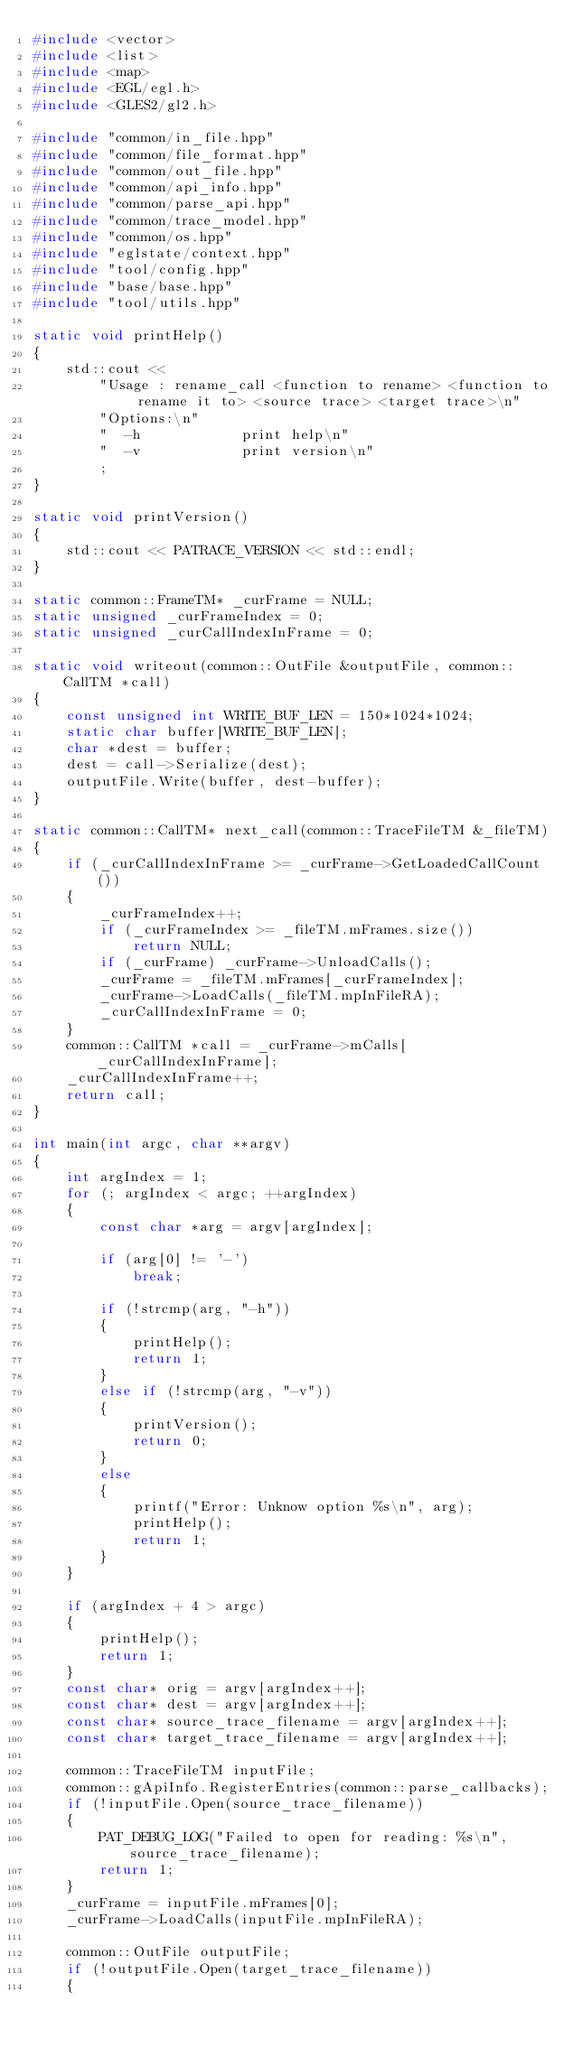<code> <loc_0><loc_0><loc_500><loc_500><_C++_>#include <vector>
#include <list>
#include <map>
#include <EGL/egl.h>
#include <GLES2/gl2.h>

#include "common/in_file.hpp"
#include "common/file_format.hpp"
#include "common/out_file.hpp"
#include "common/api_info.hpp"
#include "common/parse_api.hpp"
#include "common/trace_model.hpp"
#include "common/os.hpp"
#include "eglstate/context.hpp"
#include "tool/config.hpp"
#include "base/base.hpp"
#include "tool/utils.hpp"

static void printHelp()
{
    std::cout <<
        "Usage : rename_call <function to rename> <function to rename it to> <source trace> <target trace>\n"
        "Options:\n"
        "  -h            print help\n"
        "  -v            print version\n"
        ;
}

static void printVersion()
{
    std::cout << PATRACE_VERSION << std::endl;
}

static common::FrameTM* _curFrame = NULL;
static unsigned _curFrameIndex = 0;
static unsigned _curCallIndexInFrame = 0;

static void writeout(common::OutFile &outputFile, common::CallTM *call)
{
    const unsigned int WRITE_BUF_LEN = 150*1024*1024;
    static char buffer[WRITE_BUF_LEN];
    char *dest = buffer;
    dest = call->Serialize(dest);
    outputFile.Write(buffer, dest-buffer);
}

static common::CallTM* next_call(common::TraceFileTM &_fileTM)
{
    if (_curCallIndexInFrame >= _curFrame->GetLoadedCallCount())
    {
        _curFrameIndex++;
        if (_curFrameIndex >= _fileTM.mFrames.size())
            return NULL;
        if (_curFrame) _curFrame->UnloadCalls();
        _curFrame = _fileTM.mFrames[_curFrameIndex];
        _curFrame->LoadCalls(_fileTM.mpInFileRA);
        _curCallIndexInFrame = 0;
    }
    common::CallTM *call = _curFrame->mCalls[_curCallIndexInFrame];
    _curCallIndexInFrame++;
    return call;
}

int main(int argc, char **argv)
{
    int argIndex = 1;
    for (; argIndex < argc; ++argIndex)
    {
        const char *arg = argv[argIndex];

        if (arg[0] != '-')
            break;

        if (!strcmp(arg, "-h"))
        {
            printHelp();
            return 1;
        }
        else if (!strcmp(arg, "-v"))
        {
            printVersion();
            return 0;
        }
        else
        {
            printf("Error: Unknow option %s\n", arg);
            printHelp();
            return 1;
        }
    }

    if (argIndex + 4 > argc)
    {
        printHelp();
        return 1;
    }
    const char* orig = argv[argIndex++];
    const char* dest = argv[argIndex++];
    const char* source_trace_filename = argv[argIndex++];
    const char* target_trace_filename = argv[argIndex++];

    common::TraceFileTM inputFile;
    common::gApiInfo.RegisterEntries(common::parse_callbacks);
    if (!inputFile.Open(source_trace_filename))
    {
        PAT_DEBUG_LOG("Failed to open for reading: %s\n", source_trace_filename);
        return 1;
    }
    _curFrame = inputFile.mFrames[0];
    _curFrame->LoadCalls(inputFile.mpInFileRA);

    common::OutFile outputFile;
    if (!outputFile.Open(target_trace_filename))
    {</code> 